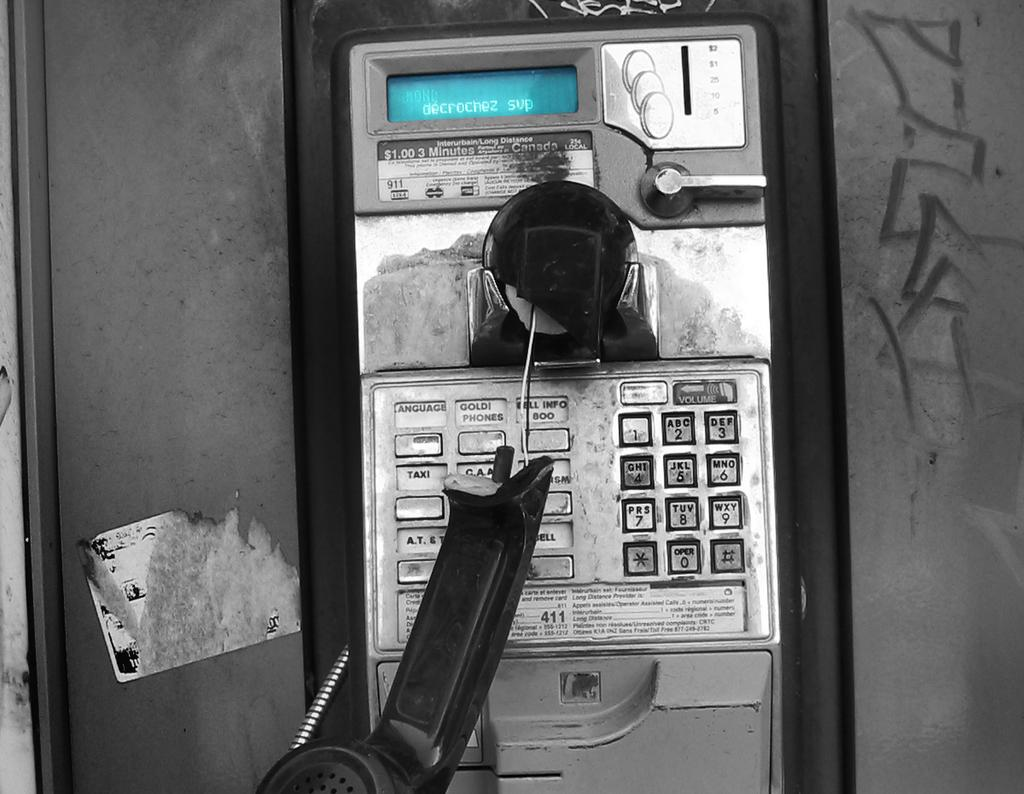<image>
Describe the image concisely. A broken handset from a payphone that charges $1.00 for 3 minutes. 